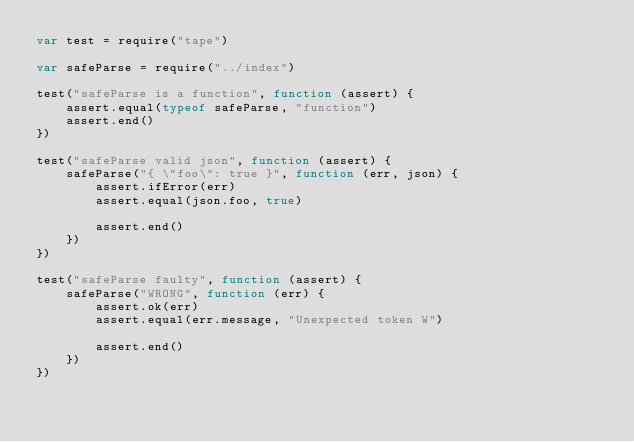<code> <loc_0><loc_0><loc_500><loc_500><_JavaScript_>var test = require("tape")

var safeParse = require("../index")

test("safeParse is a function", function (assert) {
    assert.equal(typeof safeParse, "function")
    assert.end()
})

test("safeParse valid json", function (assert) {
    safeParse("{ \"foo\": true }", function (err, json) {
        assert.ifError(err)
        assert.equal(json.foo, true)

        assert.end()
    })
})

test("safeParse faulty", function (assert) {
    safeParse("WRONG", function (err) {
        assert.ok(err)
        assert.equal(err.message, "Unexpected token W")

        assert.end()
    })
})
</code> 